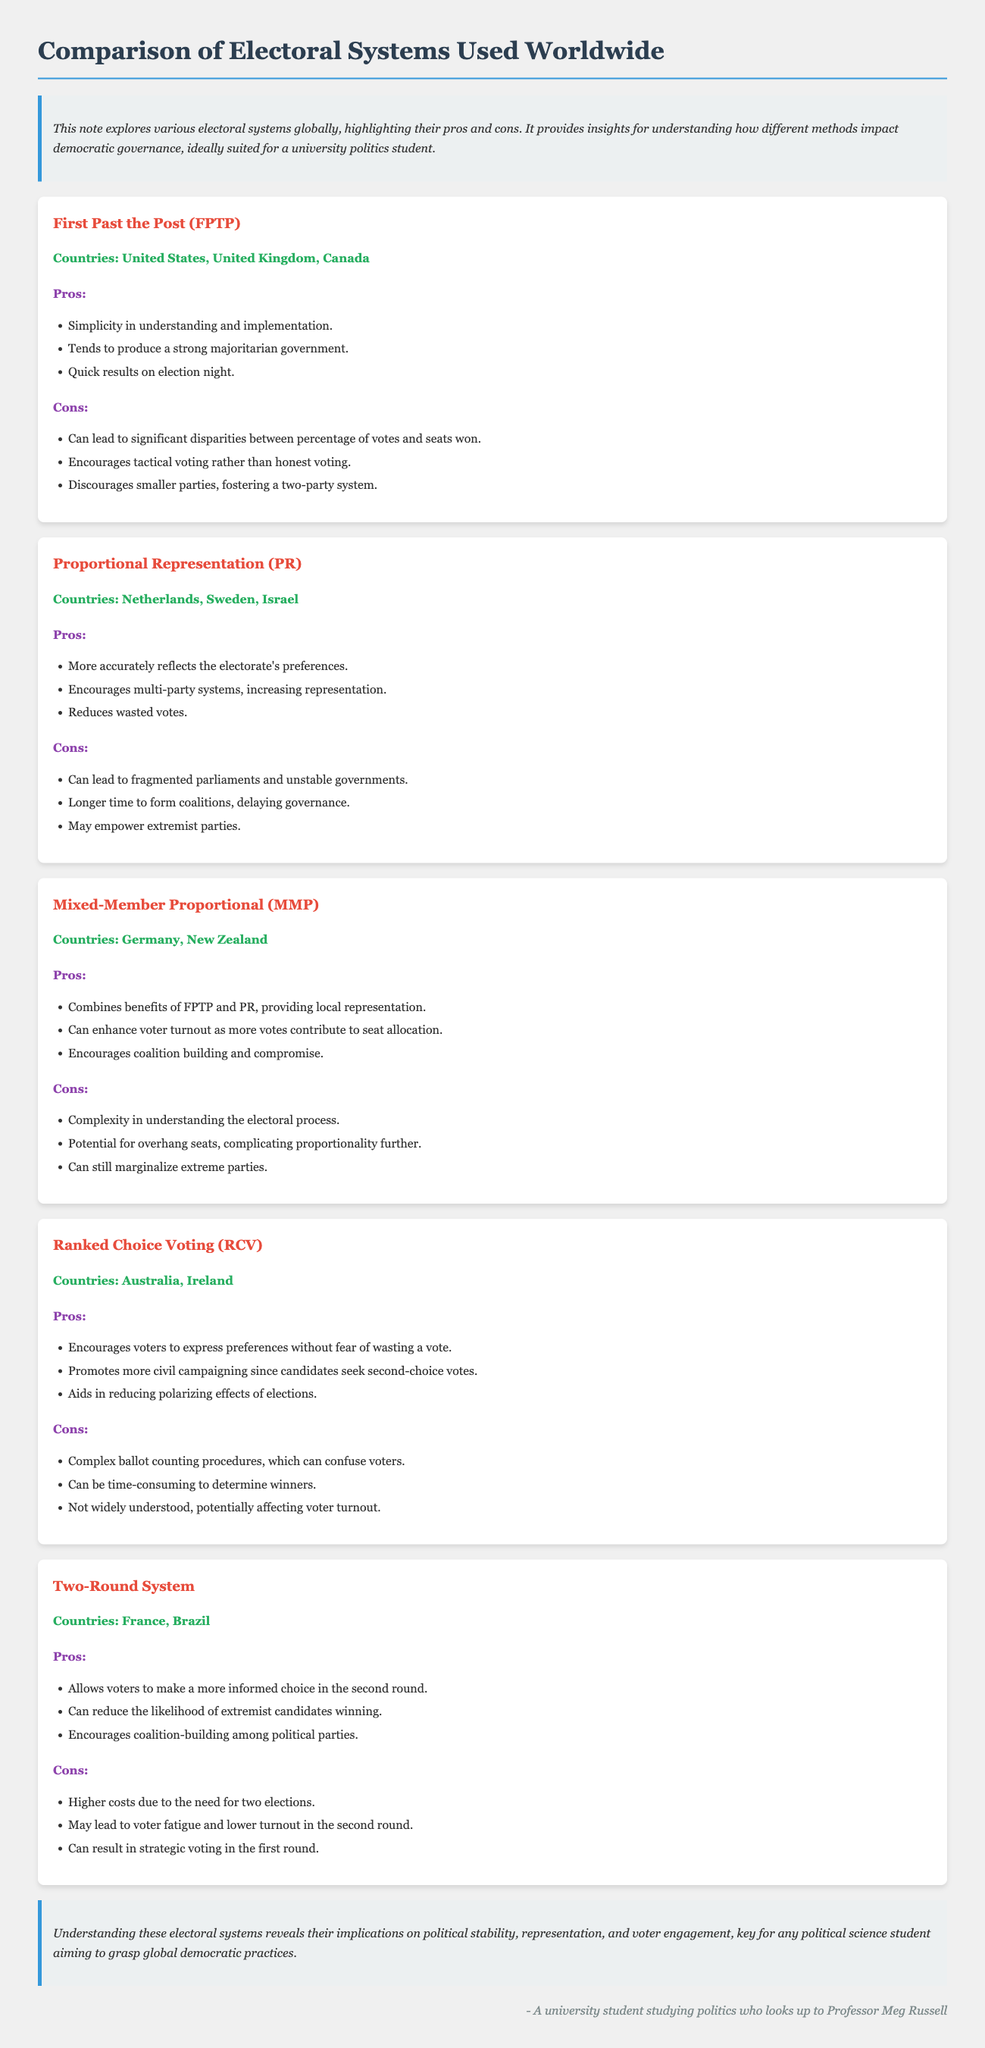What are the countries that use First Past the Post? The countries listed under First Past the Post include the United States, United Kingdom, and Canada.
Answer: United States, United Kingdom, Canada What is one pro of Proportional Representation? One of the advantages of Proportional Representation is that it more accurately reflects the electorate's preferences.
Answer: More accurately reflects the electorate's preferences What is one con of Ranked Choice Voting? A drawback of Ranked Choice Voting is the complex ballot counting procedures, which can confuse voters.
Answer: Complex ballot counting procedures How many electoral systems are compared in the document? The document presents a comparison of five different electoral systems.
Answer: Five Which electoral system encourages coalition building among political parties? The Two-Round System encourages coalition-building among political parties, as noted in its pros.
Answer: Two-Round System What is a benefit of Mixed-Member Proportional? One benefit of Mixed-Member Proportional is that it combines benefits of FPTP and PR, providing local representation.
Answer: Combines benefits of FPTP and PR Why might Proportional Representation lead to fragmented parliaments? Proportional Representation can lead to fragmented parliaments because it encourages multi-party systems, which increases representation.
Answer: Encourages multi-party systems What is mentioned as a drawback of the Two-Round System? A noted drawback of the Two-Round System is higher costs due to the need for two elections.
Answer: Higher costs due to the need for two elections 